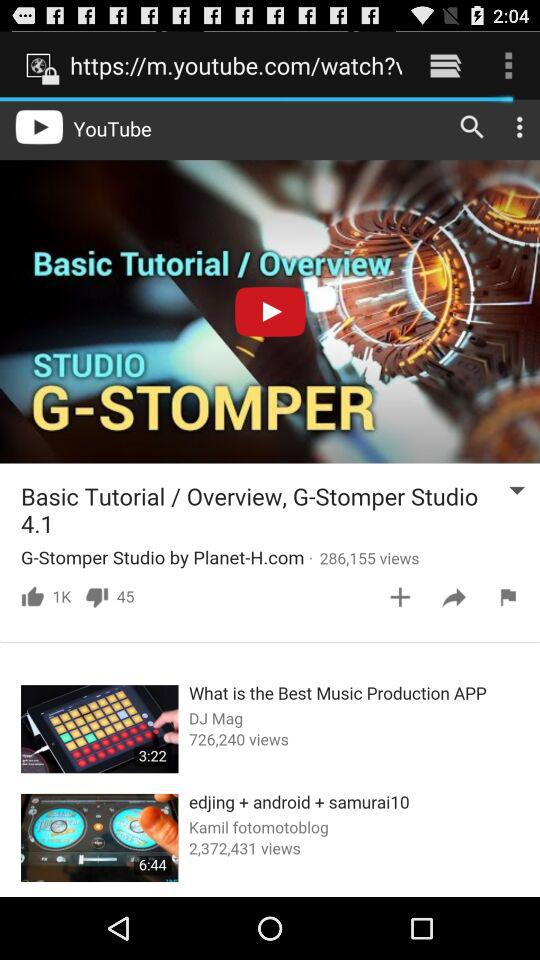What is the duration of the "edjing + android + samurai10" video? The duration of the video is 6:44. 